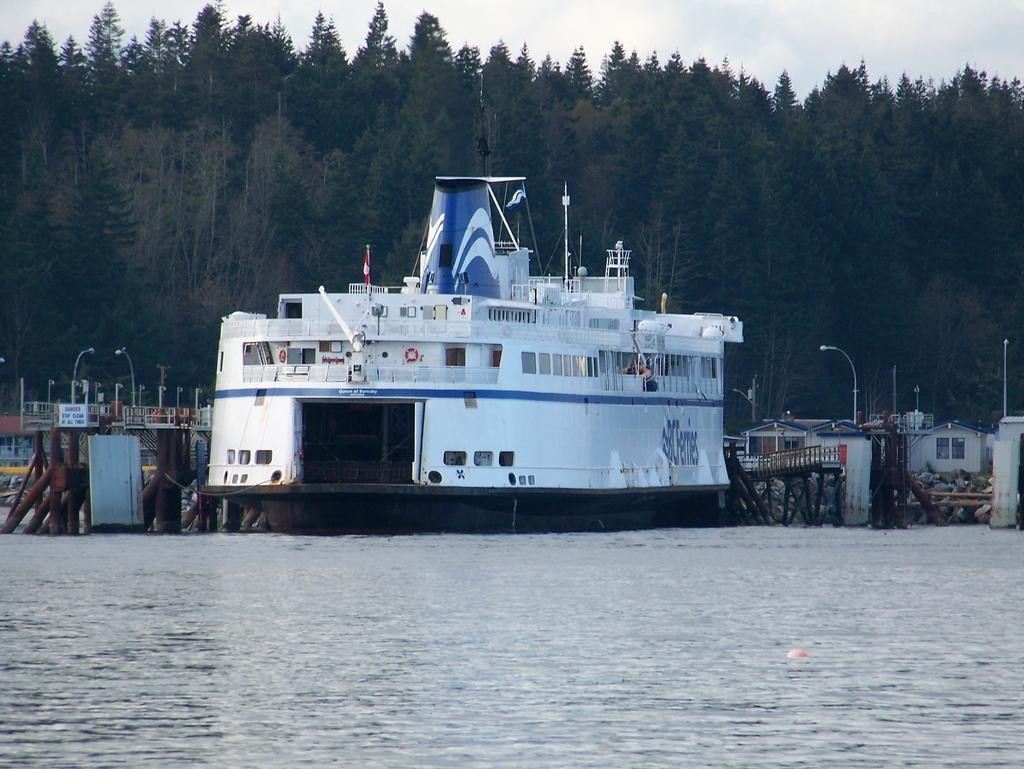What is located in the water in the image? There is a ship in the water in the image. What structure can be seen in the image? There is a bridge in the image. What are the poles in the image used for? The poles in the image are likely used for supporting structures or providing guidance. What can be seen in the image that provides illumination? There are lights in the image. What type of man-made structures are visible in the image? There are buildings in the image. What type of natural vegetation is visible in the image? There are trees in the image. What is visible in the background of the image? The sky is visible in the background of the image. Can you tell me how many friends are sitting on the ship in the image? There is no information about friends or people sitting on the ship in the image. What type of arithmetic problem can be solved using the lights in the image? There is no arithmetic problem present in the image; it features a ship, a bridge, poles, lights, buildings, trees, and a visible sky. 